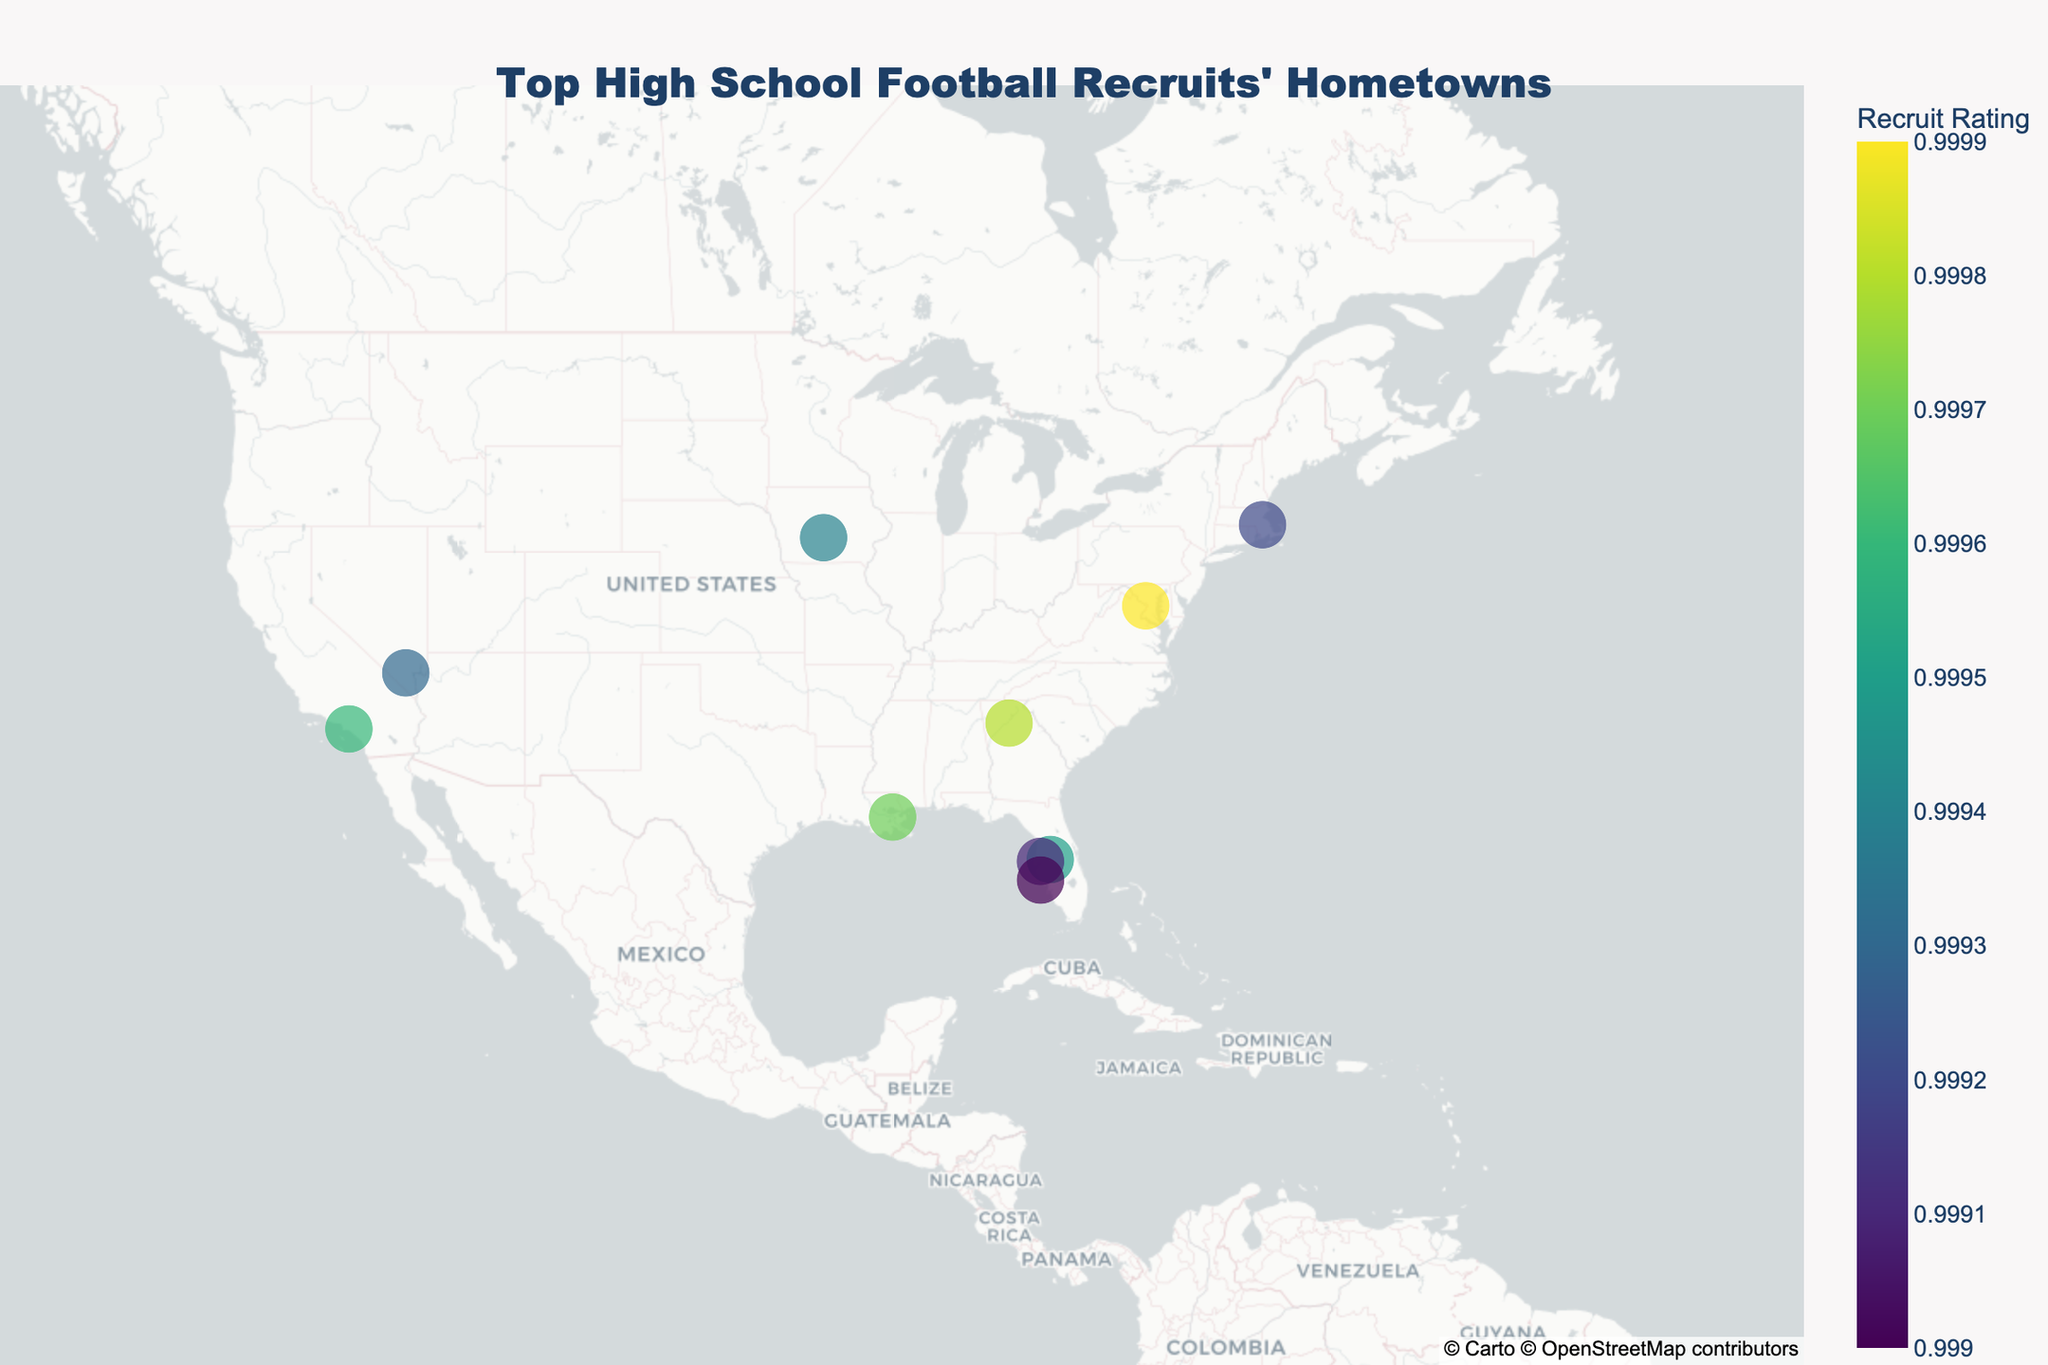How many recruits are mapped on the plot? By inspecting the plot, we can count the number of points that represent the recruits mapped on the figure.
Answer: 10 Which recruit has the highest rating and where is he from? The highest rating can be identified by looking for the largest and darkest point on the map, then cross-referencing the hover information to find the recruit's name and hometown.
Answer: Caleb Williams, Washington, DC Are there more recruits from Florida than California? To determine this, we count the number of points (recruits) for Florida and California respectively. From the hover data, identify the recruits and their states.
Answer: Yes How many recruits are quarterbacks (QBs)? To find this, refer to the hover information on the map and count the number of recruits marked as "QB" under the position category.
Answer: 3 Which state has the highest number of top high school football recruits? This requires counting the recruits per state by inspecting the points and their respective hover information.
Answer: Florida What is the average rating of the recruits? Sum the ratings of all 10 recruits and divide by the number of recruits: (0.9999 + 0.9998 + 0.9997 + 0.9996 + 0.9995 + 0.9994 + 0.9993 + 0.9992 + 0.9991 + 0.9990) / 10 = 0.99945
Answer: 0.99945 Which recruit has the lowest rating and where is he from? Identify the smallest and lightest shaded point on the map and check the hover information for their details.
Answer: Damon Wilson, Venice, FL Is there a recruit from Las Vegas, NV? Inspect the map and hover data to check for a recruit whose hometown and state are listed as Las Vegas, NV.
Answer: Yes Which recruit has a rating closest to 0.9995 and what is his position? The recruit with a rating of 0.9995 can be identified directly by referring to the hover data on the plot.
Answer: Cormani McClain, CB 